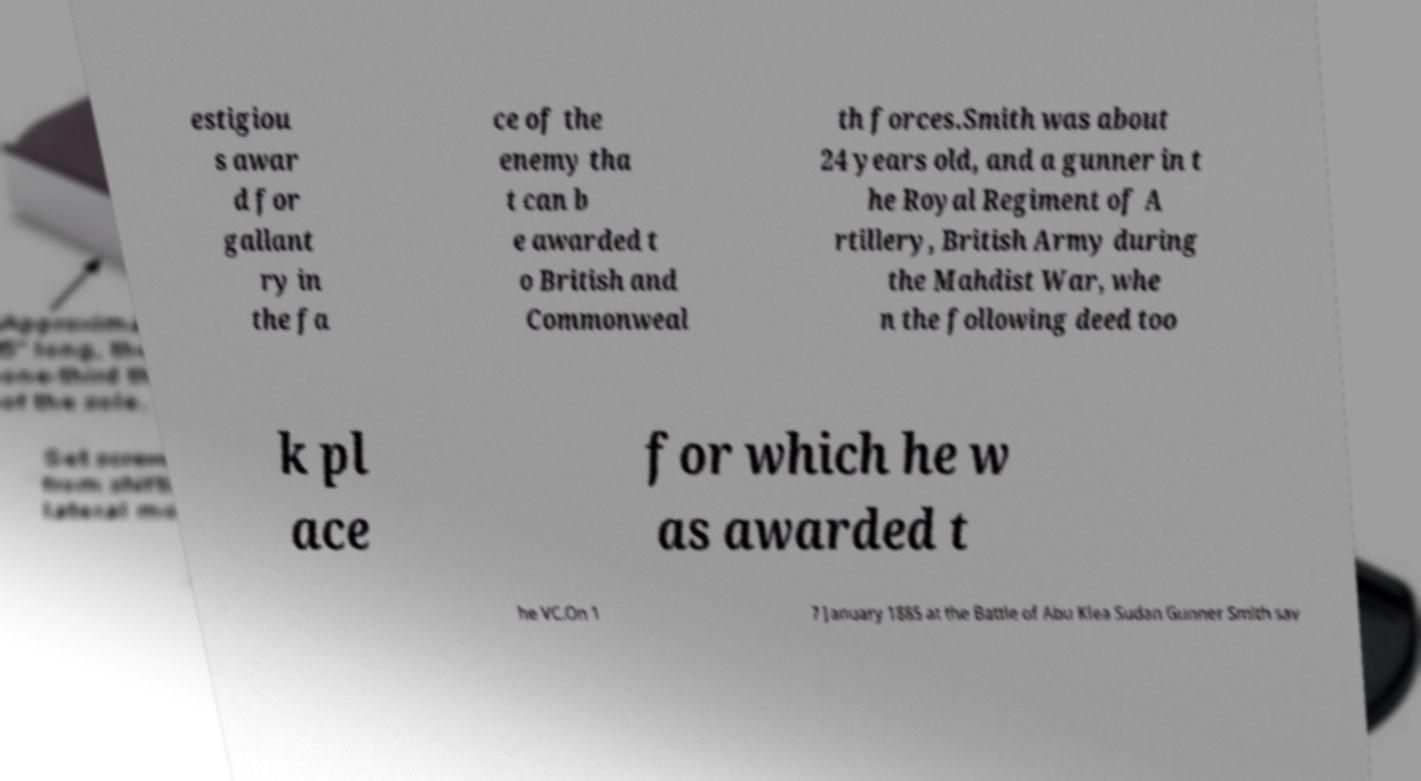Can you read and provide the text displayed in the image?This photo seems to have some interesting text. Can you extract and type it out for me? estigiou s awar d for gallant ry in the fa ce of the enemy tha t can b e awarded t o British and Commonweal th forces.Smith was about 24 years old, and a gunner in t he Royal Regiment of A rtillery, British Army during the Mahdist War, whe n the following deed too k pl ace for which he w as awarded t he VC.On 1 7 January 1885 at the Battle of Abu Klea Sudan Gunner Smith sav 